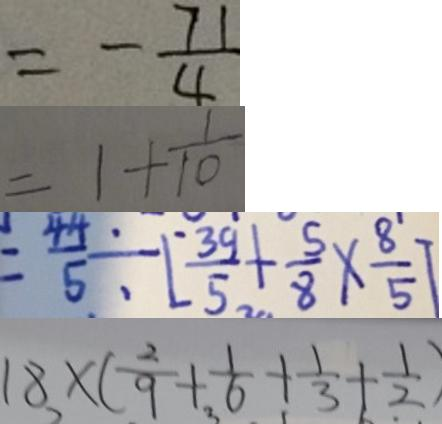Convert formula to latex. <formula><loc_0><loc_0><loc_500><loc_500>= - \frac { 7 1 } { 4 } 
 = 1 + \frac { 1 } { 1 0 } 
 = \frac { 4 4 } { 5 } \div [ \frac { 3 9 } { 5 } + \frac { 5 } { 8 } \times \frac { 8 } { 5 } ] 
 1 8 \times ( \frac { 2 } { 9 } + \frac { 1 } { 6 } + \frac { 1 } { 3 } + \frac { 1 } { 2 } )</formula> 